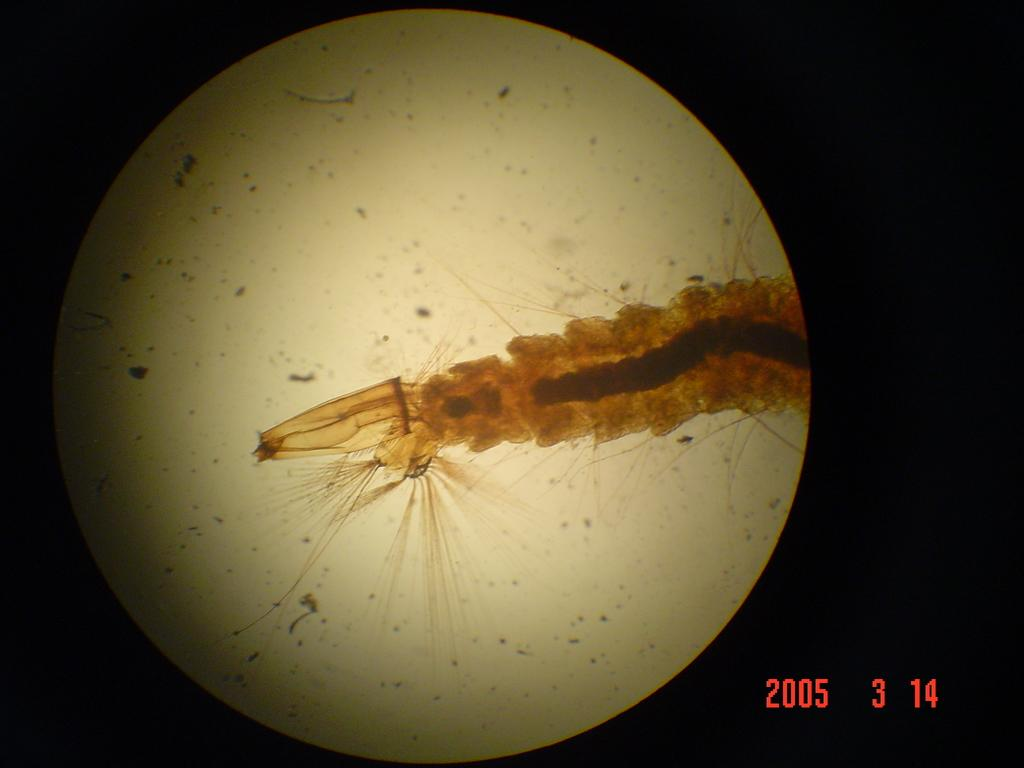What is the main subject of the image? The main subject of the image is a graphical representation of the moon. What can be observed about the background of the image? The background of the image is dark. Are there any additional elements present in the image? Yes, there are numbers present at the right bottom of the image. What type of crime is being committed in the image? There is no crime present in the image; it is a graphical representation of the moon. Can you see any cows in the image? There are no cows present in the image; it is a graphical representation of the moon. 